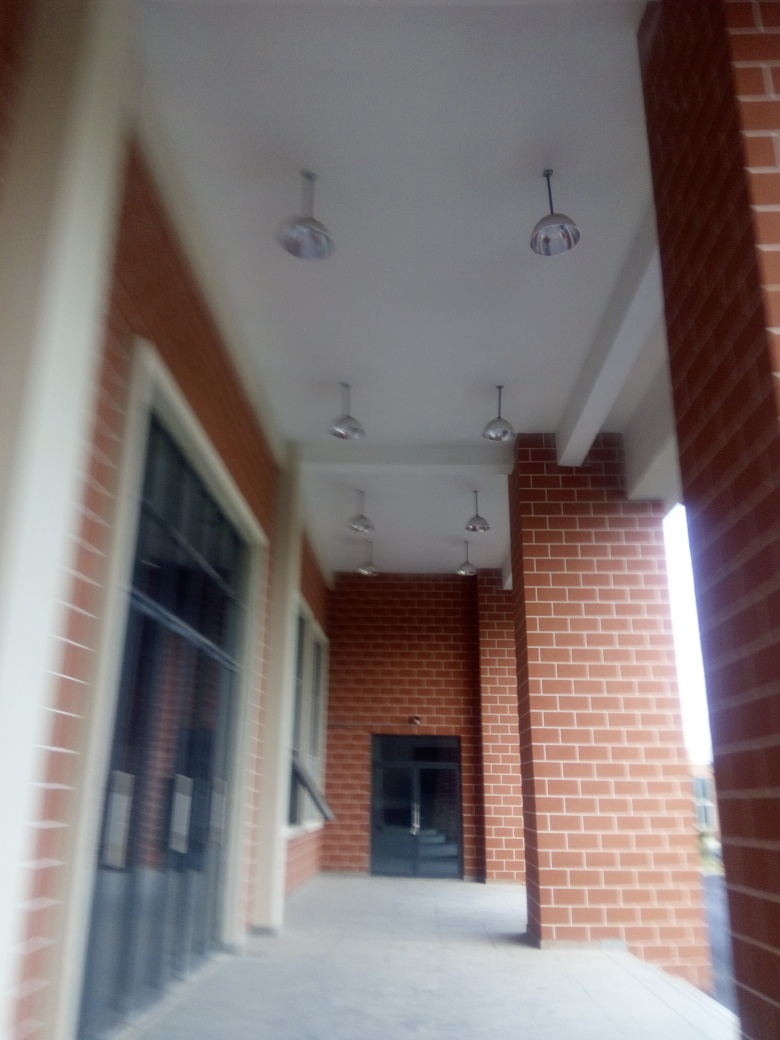How is the clarity of this image? The clarity of this image is relatively low due to evident blurriness and lack of focus which obscures fine details on the architecture and surroundings. 